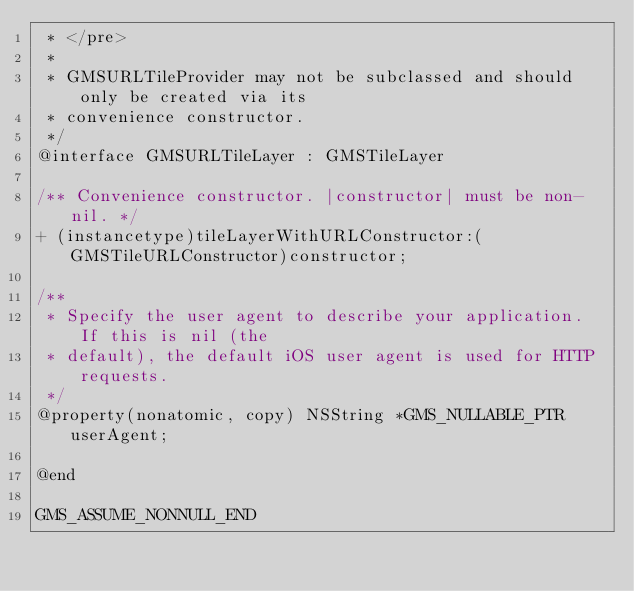Convert code to text. <code><loc_0><loc_0><loc_500><loc_500><_C_> * </pre>
 *
 * GMSURLTileProvider may not be subclassed and should only be created via its
 * convenience constructor.
 */
@interface GMSURLTileLayer : GMSTileLayer

/** Convenience constructor. |constructor| must be non-nil. */
+ (instancetype)tileLayerWithURLConstructor:(GMSTileURLConstructor)constructor;

/**
 * Specify the user agent to describe your application. If this is nil (the
 * default), the default iOS user agent is used for HTTP requests.
 */
@property(nonatomic, copy) NSString *GMS_NULLABLE_PTR userAgent;

@end

GMS_ASSUME_NONNULL_END
</code> 